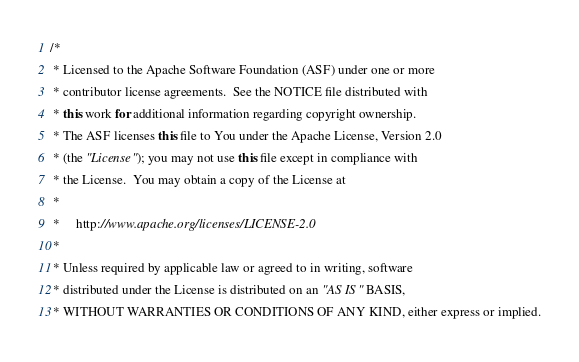Convert code to text. <code><loc_0><loc_0><loc_500><loc_500><_Java_>/*
 * Licensed to the Apache Software Foundation (ASF) under one or more
 * contributor license agreements.  See the NOTICE file distributed with
 * this work for additional information regarding copyright ownership.
 * The ASF licenses this file to You under the Apache License, Version 2.0
 * (the "License"); you may not use this file except in compliance with
 * the License.  You may obtain a copy of the License at
 *
 *     http://www.apache.org/licenses/LICENSE-2.0
 *
 * Unless required by applicable law or agreed to in writing, software
 * distributed under the License is distributed on an "AS IS" BASIS,
 * WITHOUT WARRANTIES OR CONDITIONS OF ANY KIND, either express or implied.</code> 